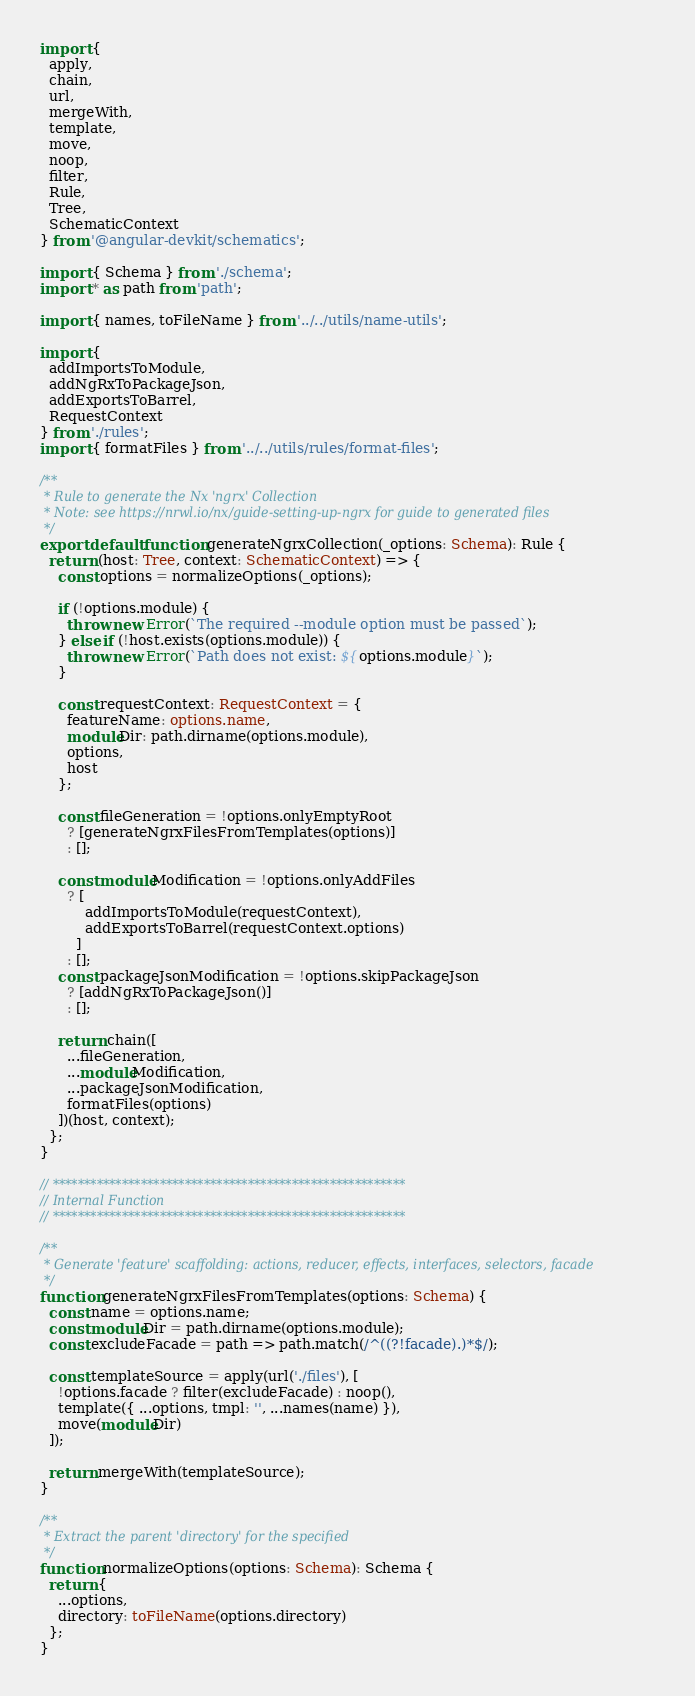Convert code to text. <code><loc_0><loc_0><loc_500><loc_500><_TypeScript_>import {
  apply,
  chain,
  url,
  mergeWith,
  template,
  move,
  noop,
  filter,
  Rule,
  Tree,
  SchematicContext
} from '@angular-devkit/schematics';

import { Schema } from './schema';
import * as path from 'path';

import { names, toFileName } from '../../utils/name-utils';

import {
  addImportsToModule,
  addNgRxToPackageJson,
  addExportsToBarrel,
  RequestContext
} from './rules';
import { formatFiles } from '../../utils/rules/format-files';

/**
 * Rule to generate the Nx 'ngrx' Collection
 * Note: see https://nrwl.io/nx/guide-setting-up-ngrx for guide to generated files
 */
export default function generateNgrxCollection(_options: Schema): Rule {
  return (host: Tree, context: SchematicContext) => {
    const options = normalizeOptions(_options);

    if (!options.module) {
      throw new Error(`The required --module option must be passed`);
    } else if (!host.exists(options.module)) {
      throw new Error(`Path does not exist: ${options.module}`);
    }

    const requestContext: RequestContext = {
      featureName: options.name,
      moduleDir: path.dirname(options.module),
      options,
      host
    };

    const fileGeneration = !options.onlyEmptyRoot
      ? [generateNgrxFilesFromTemplates(options)]
      : [];

    const moduleModification = !options.onlyAddFiles
      ? [
          addImportsToModule(requestContext),
          addExportsToBarrel(requestContext.options)
        ]
      : [];
    const packageJsonModification = !options.skipPackageJson
      ? [addNgRxToPackageJson()]
      : [];

    return chain([
      ...fileGeneration,
      ...moduleModification,
      ...packageJsonModification,
      formatFiles(options)
    ])(host, context);
  };
}

// ********************************************************
// Internal Function
// ********************************************************

/**
 * Generate 'feature' scaffolding: actions, reducer, effects, interfaces, selectors, facade
 */
function generateNgrxFilesFromTemplates(options: Schema) {
  const name = options.name;
  const moduleDir = path.dirname(options.module);
  const excludeFacade = path => path.match(/^((?!facade).)*$/);

  const templateSource = apply(url('./files'), [
    !options.facade ? filter(excludeFacade) : noop(),
    template({ ...options, tmpl: '', ...names(name) }),
    move(moduleDir)
  ]);

  return mergeWith(templateSource);
}

/**
 * Extract the parent 'directory' for the specified
 */
function normalizeOptions(options: Schema): Schema {
  return {
    ...options,
    directory: toFileName(options.directory)
  };
}
</code> 